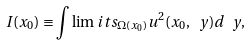Convert formula to latex. <formula><loc_0><loc_0><loc_500><loc_500>I ( x _ { 0 } ) \equiv \int \lim i t s _ { \Omega ( x _ { 0 } ) } u ^ { 2 } ( x _ { 0 } , \ y ) d \ y ,</formula> 